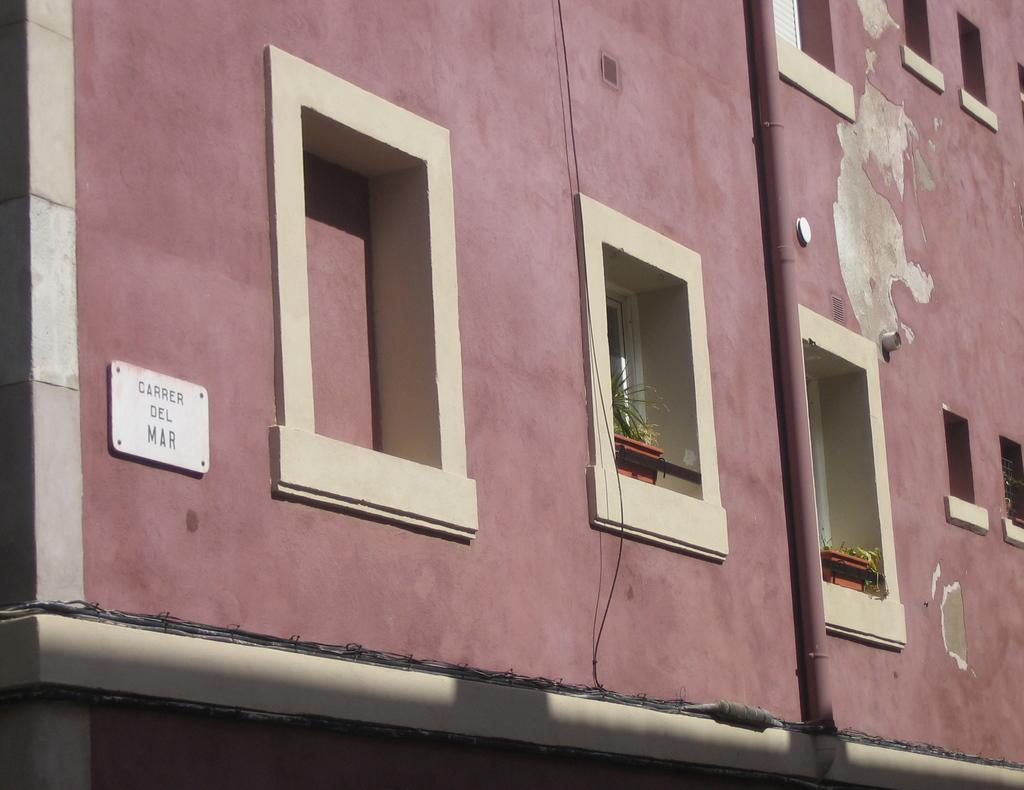What type of structure is present in the image? There is a building in the image. How can the building be identified? The building has a name plate. What architectural features can be seen on the building? There are pipes visible on the building. What decorative elements are present on the building? There are flower pots on the balconies of the building. What type of corn is growing in the flower pots on the balconies of the building? There is no corn present in the image; the flower pots contain flowers. 